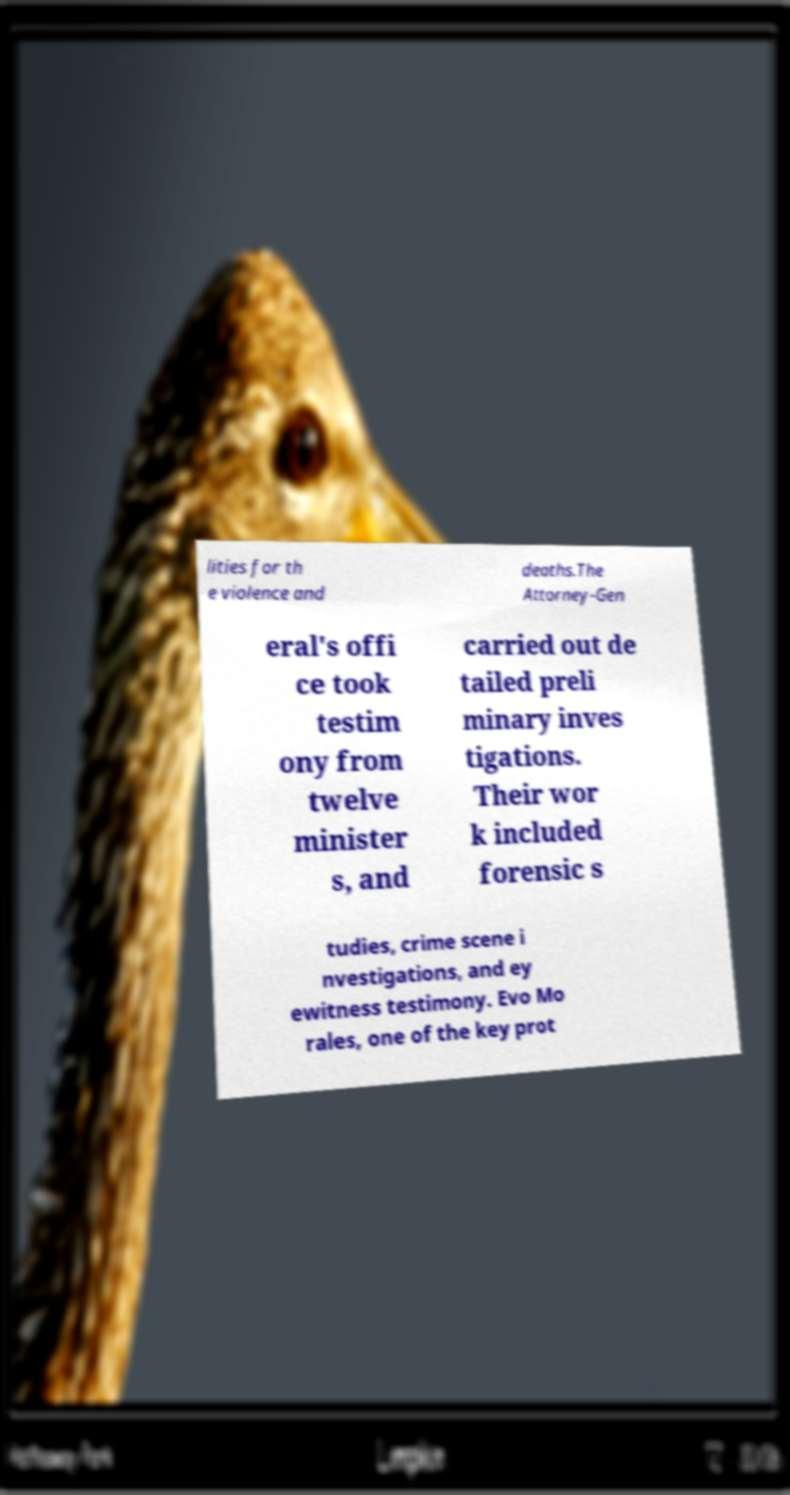What messages or text are displayed in this image? I need them in a readable, typed format. lities for th e violence and deaths.The Attorney-Gen eral's offi ce took testim ony from twelve minister s, and carried out de tailed preli minary inves tigations. Their wor k included forensic s tudies, crime scene i nvestigations, and ey ewitness testimony. Evo Mo rales, one of the key prot 